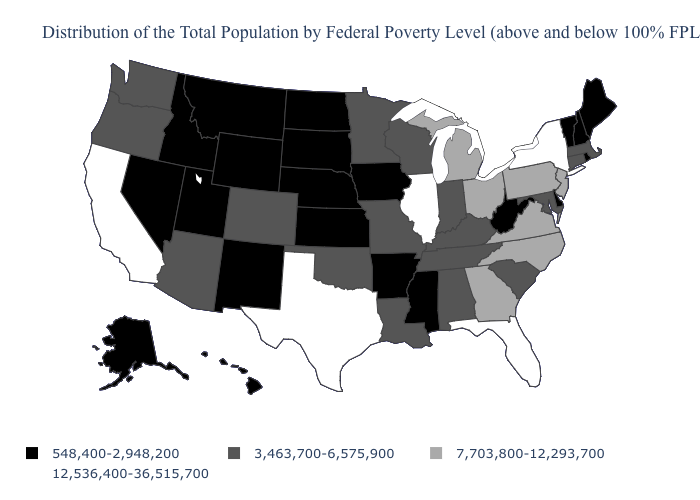What is the value of Wyoming?
Answer briefly. 548,400-2,948,200. Does Arizona have the highest value in the West?
Write a very short answer. No. Name the states that have a value in the range 12,536,400-36,515,700?
Concise answer only. California, Florida, Illinois, New York, Texas. What is the value of Virginia?
Be succinct. 7,703,800-12,293,700. Which states have the lowest value in the USA?
Answer briefly. Alaska, Arkansas, Delaware, Hawaii, Idaho, Iowa, Kansas, Maine, Mississippi, Montana, Nebraska, Nevada, New Hampshire, New Mexico, North Dakota, Rhode Island, South Dakota, Utah, Vermont, West Virginia, Wyoming. Which states have the lowest value in the MidWest?
Answer briefly. Iowa, Kansas, Nebraska, North Dakota, South Dakota. Does New Hampshire have the lowest value in the USA?
Give a very brief answer. Yes. Does Florida have the highest value in the USA?
Be succinct. Yes. Which states have the lowest value in the MidWest?
Short answer required. Iowa, Kansas, Nebraska, North Dakota, South Dakota. How many symbols are there in the legend?
Quick response, please. 4. What is the value of West Virginia?
Be succinct. 548,400-2,948,200. Does Pennsylvania have the lowest value in the Northeast?
Write a very short answer. No. What is the value of Delaware?
Concise answer only. 548,400-2,948,200. Does the map have missing data?
Write a very short answer. No. 